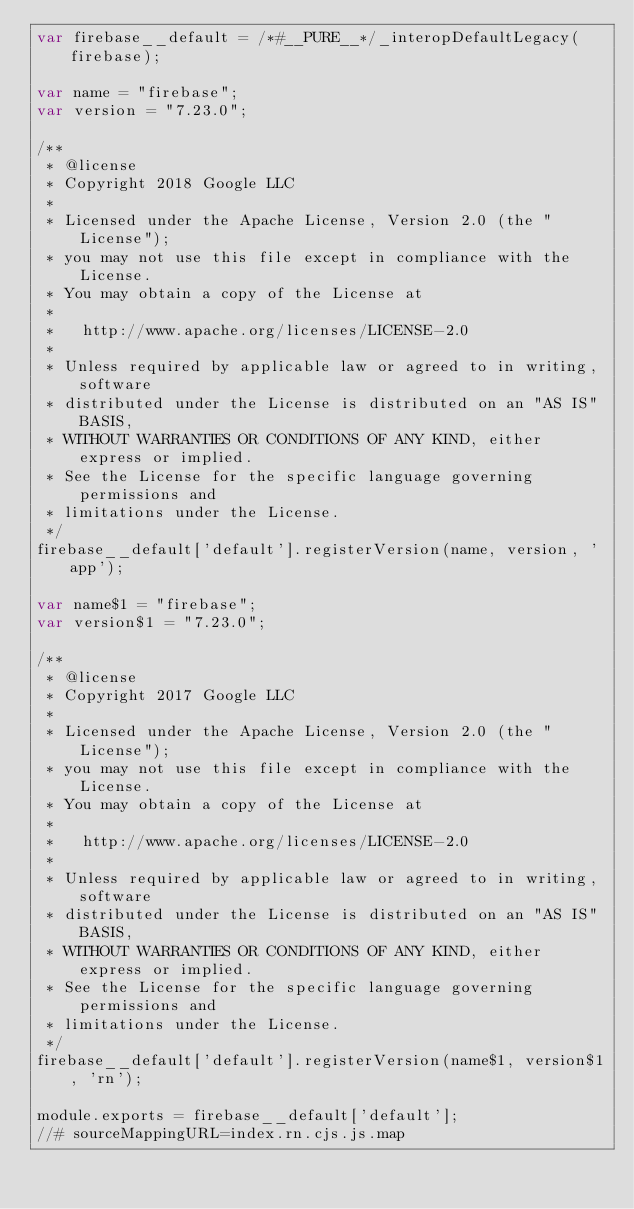Convert code to text. <code><loc_0><loc_0><loc_500><loc_500><_JavaScript_>var firebase__default = /*#__PURE__*/_interopDefaultLegacy(firebase);

var name = "firebase";
var version = "7.23.0";

/**
 * @license
 * Copyright 2018 Google LLC
 *
 * Licensed under the Apache License, Version 2.0 (the "License");
 * you may not use this file except in compliance with the License.
 * You may obtain a copy of the License at
 *
 *   http://www.apache.org/licenses/LICENSE-2.0
 *
 * Unless required by applicable law or agreed to in writing, software
 * distributed under the License is distributed on an "AS IS" BASIS,
 * WITHOUT WARRANTIES OR CONDITIONS OF ANY KIND, either express or implied.
 * See the License for the specific language governing permissions and
 * limitations under the License.
 */
firebase__default['default'].registerVersion(name, version, 'app');

var name$1 = "firebase";
var version$1 = "7.23.0";

/**
 * @license
 * Copyright 2017 Google LLC
 *
 * Licensed under the Apache License, Version 2.0 (the "License");
 * you may not use this file except in compliance with the License.
 * You may obtain a copy of the License at
 *
 *   http://www.apache.org/licenses/LICENSE-2.0
 *
 * Unless required by applicable law or agreed to in writing, software
 * distributed under the License is distributed on an "AS IS" BASIS,
 * WITHOUT WARRANTIES OR CONDITIONS OF ANY KIND, either express or implied.
 * See the License for the specific language governing permissions and
 * limitations under the License.
 */
firebase__default['default'].registerVersion(name$1, version$1, 'rn');

module.exports = firebase__default['default'];
//# sourceMappingURL=index.rn.cjs.js.map
</code> 